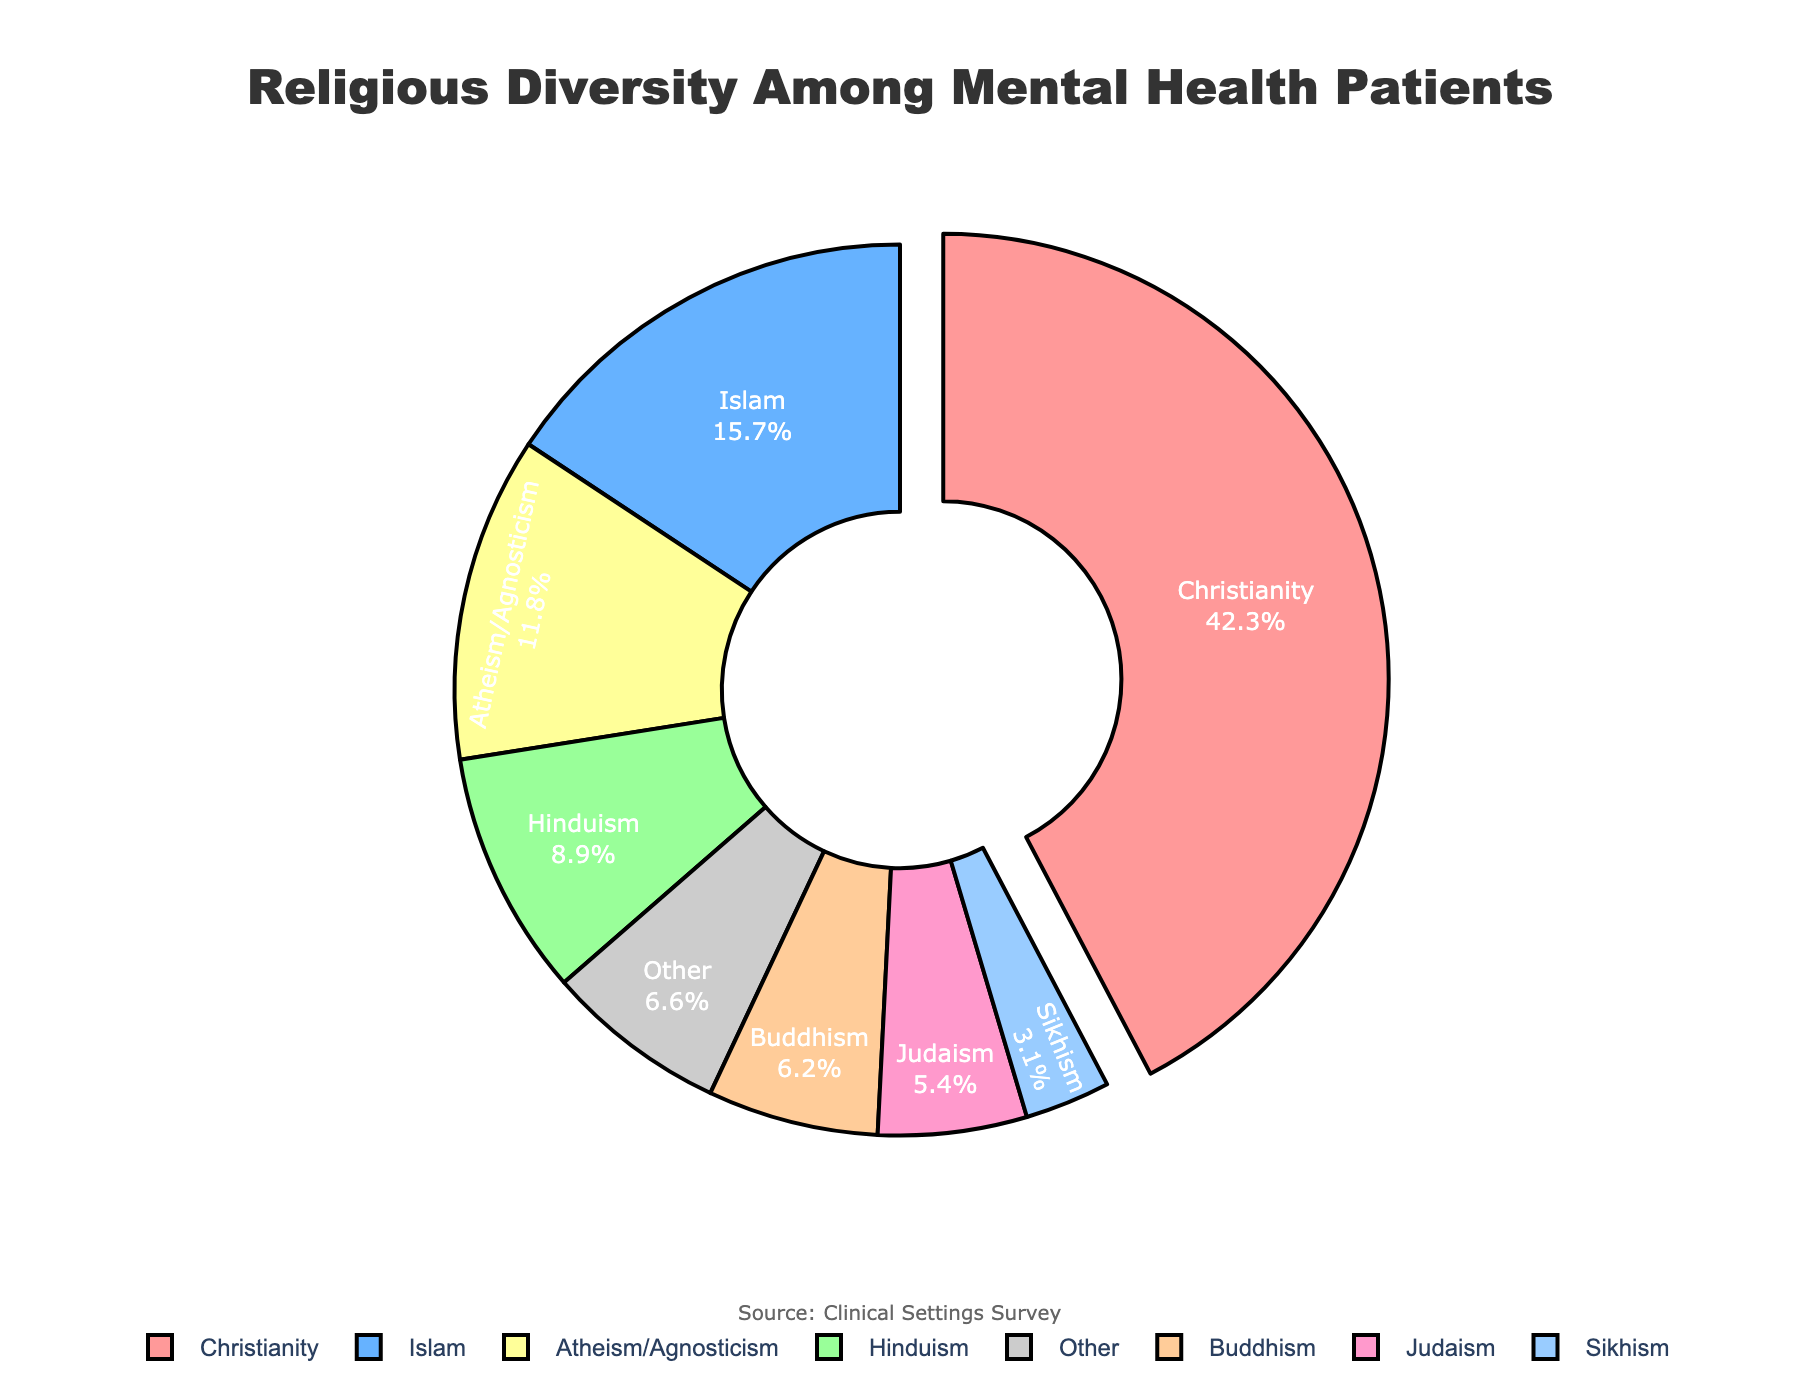Which religion has the largest percentage among patients seeking mental health treatment? The largest percentage can be determined by observing the segment that is pulled out, as well as the percentage labels. Christianity is 42.3%, which is the largest.
Answer: Christianity What is the combined percentage of patients identifying as Islam and Hinduism? Add the percentages of Islam (15.7%) and Hinduism (8.9%). 15.7% + 8.9% = 24.6%.
Answer: 24.6% Which religion has more representation, Buddhism or Judaism? Compare the percentages of Buddhism (6.2%) and Judaism (5.4%). Buddhism has a higher percentage than Judaism.
Answer: Buddhism What is the percentage difference between Christianity and Atheism/Agnosticism? Subtract the percentage of Atheism/Agnosticism (11.8%) from Christianity (42.3%). 42.3% - 11.8% = 30.5%.
Answer: 30.5% What color represents the 'Other' category in the pie chart? By identifying the 'Other' label in the chart and its corresponding segment color, which appears gray.
Answer: Gray How many religions have a percentage higher than 10%? Identify and count the religions that have a percentage greater than 10% (Christianity, Islam, Atheism/Agnosticism).
Answer: 3 Is the percentage of patients identifying as Sikhism more or less than half of those identifying as Atheism/Agnosticism? Compare the percentage of Sikhism (3.1%) with half the percentage of Atheism/Agnosticism (11.8% / 2 = 5.9%). 3.1% is less than 5.9%.
Answer: Less What is the total percentage of patients represented by minority religions (Buddhism, Judaism, and Sikhism)? Add the percentages: Buddhism (6.2%), Judaism (5.4%), and Sikhism (3.1%). 6.2% + 5.4% + 3.1% = 14.7%.
Answer: 14.7% Which religion's segment color is closest to blue? The color of the Christianity segment is closest to blue.
Answer: Christianity What percentage of patients identify with a religion other than the top two most common ones (Christianity and Islam)? Subtract the combined percentage of Christianity (42.3%) and Islam (15.7%) from 100%. 100% - (42.3% + 15.7%) = 42%.
Answer: 42% 